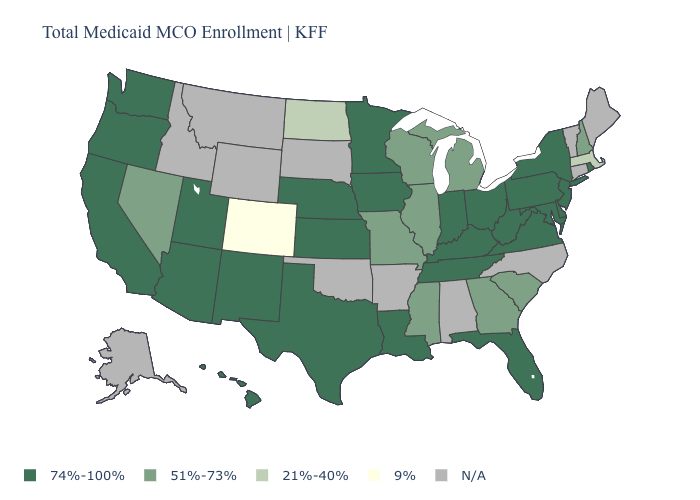Name the states that have a value in the range 51%-73%?
Keep it brief. Georgia, Illinois, Michigan, Mississippi, Missouri, Nevada, New Hampshire, South Carolina, Wisconsin. Name the states that have a value in the range 9%?
Be succinct. Colorado. What is the highest value in the USA?
Give a very brief answer. 74%-100%. What is the lowest value in states that border West Virginia?
Answer briefly. 74%-100%. What is the value of Nevada?
Quick response, please. 51%-73%. What is the value of Kansas?
Concise answer only. 74%-100%. What is the lowest value in states that border Missouri?
Write a very short answer. 51%-73%. Among the states that border California , which have the highest value?
Be succinct. Arizona, Oregon. Does New Hampshire have the highest value in the USA?
Concise answer only. No. What is the highest value in the USA?
Concise answer only. 74%-100%. What is the value of Utah?
Short answer required. 74%-100%. How many symbols are there in the legend?
Concise answer only. 5. Does the map have missing data?
Be succinct. Yes. 